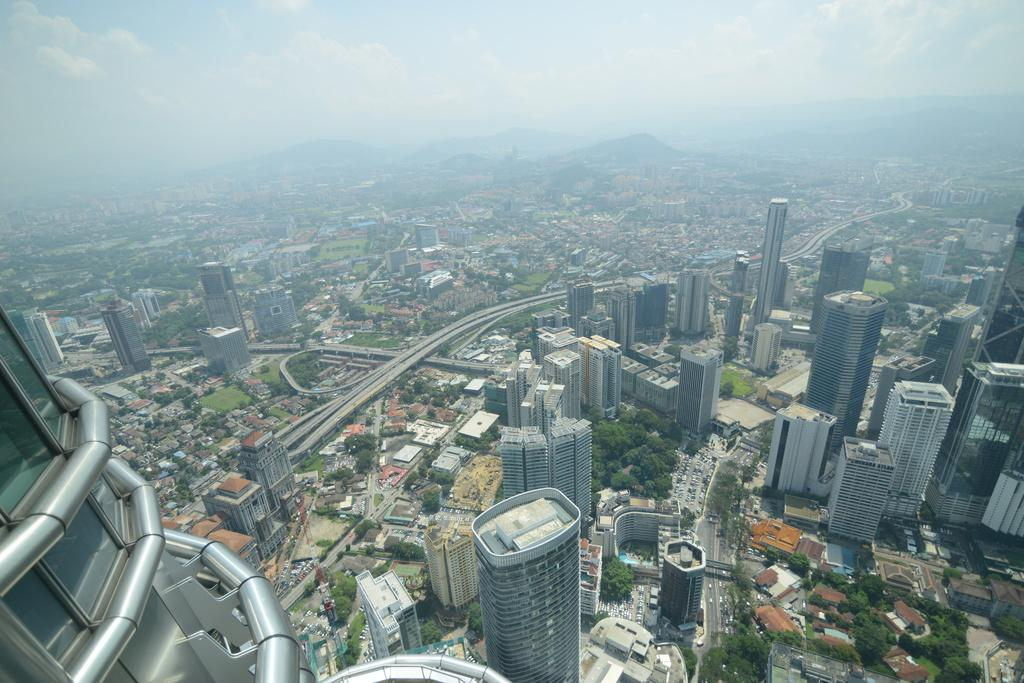What type of structures can be seen in the image? There are buildings in the image. What other natural elements are present in the image? There are trees in the image. What are the vehicles doing in the image? The vehicles are on roads in the image. What can be seen in the distance in the image? A: There are mountains visible in the background of the image. What else is visible in the background of the image? The sky is visible in the background of the image. Can you see any clovers growing in the image? There are no clovers visible in the image. What type of ship can be seen sailing in the background of the image? There is no ship present in the image; it features buildings, trees, vehicles, mountains, and the sky. 